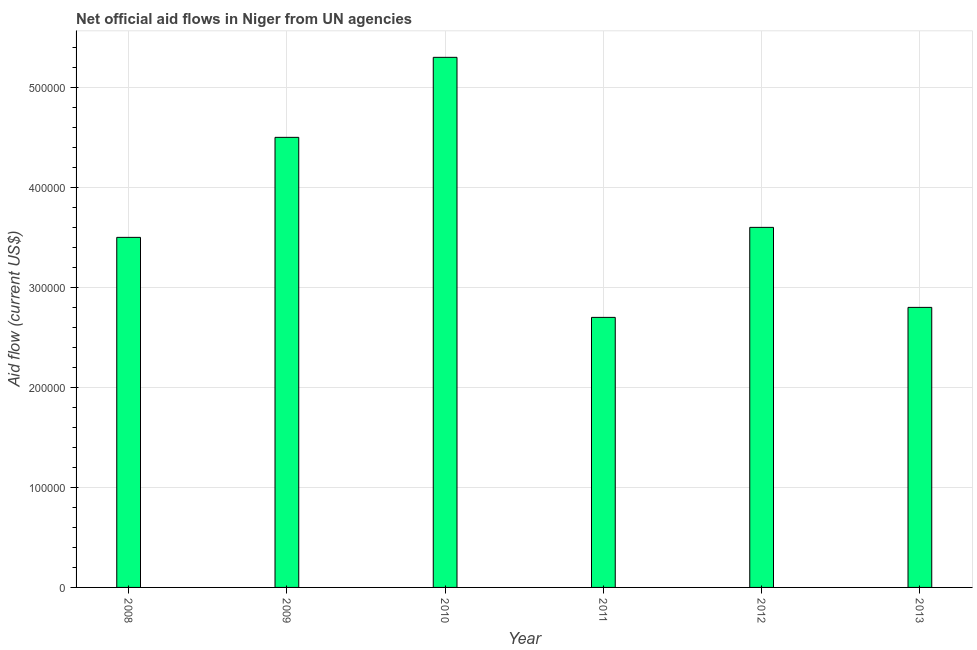Does the graph contain any zero values?
Your answer should be compact. No. What is the title of the graph?
Ensure brevity in your answer.  Net official aid flows in Niger from UN agencies. What is the label or title of the Y-axis?
Your response must be concise. Aid flow (current US$). Across all years, what is the maximum net official flows from un agencies?
Provide a short and direct response. 5.30e+05. Across all years, what is the minimum net official flows from un agencies?
Keep it short and to the point. 2.70e+05. What is the sum of the net official flows from un agencies?
Your answer should be very brief. 2.24e+06. What is the average net official flows from un agencies per year?
Your answer should be very brief. 3.73e+05. What is the median net official flows from un agencies?
Your answer should be very brief. 3.55e+05. In how many years, is the net official flows from un agencies greater than 420000 US$?
Offer a very short reply. 2. Do a majority of the years between 2008 and 2013 (inclusive) have net official flows from un agencies greater than 400000 US$?
Keep it short and to the point. No. What is the ratio of the net official flows from un agencies in 2010 to that in 2011?
Provide a succinct answer. 1.96. Is the net official flows from un agencies in 2010 less than that in 2013?
Make the answer very short. No. Is the difference between the net official flows from un agencies in 2008 and 2012 greater than the difference between any two years?
Give a very brief answer. No. Is the sum of the net official flows from un agencies in 2009 and 2013 greater than the maximum net official flows from un agencies across all years?
Make the answer very short. Yes. Are all the bars in the graph horizontal?
Your response must be concise. No. How many years are there in the graph?
Your answer should be compact. 6. What is the Aid flow (current US$) of 2009?
Give a very brief answer. 4.50e+05. What is the Aid flow (current US$) of 2010?
Provide a short and direct response. 5.30e+05. What is the Aid flow (current US$) in 2013?
Your answer should be very brief. 2.80e+05. What is the difference between the Aid flow (current US$) in 2008 and 2009?
Provide a short and direct response. -1.00e+05. What is the difference between the Aid flow (current US$) in 2008 and 2012?
Your response must be concise. -10000. What is the difference between the Aid flow (current US$) in 2009 and 2012?
Ensure brevity in your answer.  9.00e+04. What is the difference between the Aid flow (current US$) in 2009 and 2013?
Give a very brief answer. 1.70e+05. What is the difference between the Aid flow (current US$) in 2010 and 2011?
Offer a terse response. 2.60e+05. What is the difference between the Aid flow (current US$) in 2010 and 2012?
Your answer should be compact. 1.70e+05. What is the difference between the Aid flow (current US$) in 2010 and 2013?
Keep it short and to the point. 2.50e+05. What is the difference between the Aid flow (current US$) in 2011 and 2012?
Offer a terse response. -9.00e+04. What is the difference between the Aid flow (current US$) in 2011 and 2013?
Offer a very short reply. -10000. What is the ratio of the Aid flow (current US$) in 2008 to that in 2009?
Provide a short and direct response. 0.78. What is the ratio of the Aid flow (current US$) in 2008 to that in 2010?
Give a very brief answer. 0.66. What is the ratio of the Aid flow (current US$) in 2008 to that in 2011?
Keep it short and to the point. 1.3. What is the ratio of the Aid flow (current US$) in 2008 to that in 2012?
Provide a succinct answer. 0.97. What is the ratio of the Aid flow (current US$) in 2009 to that in 2010?
Your response must be concise. 0.85. What is the ratio of the Aid flow (current US$) in 2009 to that in 2011?
Your answer should be very brief. 1.67. What is the ratio of the Aid flow (current US$) in 2009 to that in 2012?
Provide a short and direct response. 1.25. What is the ratio of the Aid flow (current US$) in 2009 to that in 2013?
Your answer should be very brief. 1.61. What is the ratio of the Aid flow (current US$) in 2010 to that in 2011?
Make the answer very short. 1.96. What is the ratio of the Aid flow (current US$) in 2010 to that in 2012?
Provide a short and direct response. 1.47. What is the ratio of the Aid flow (current US$) in 2010 to that in 2013?
Offer a terse response. 1.89. What is the ratio of the Aid flow (current US$) in 2011 to that in 2013?
Keep it short and to the point. 0.96. What is the ratio of the Aid flow (current US$) in 2012 to that in 2013?
Ensure brevity in your answer.  1.29. 